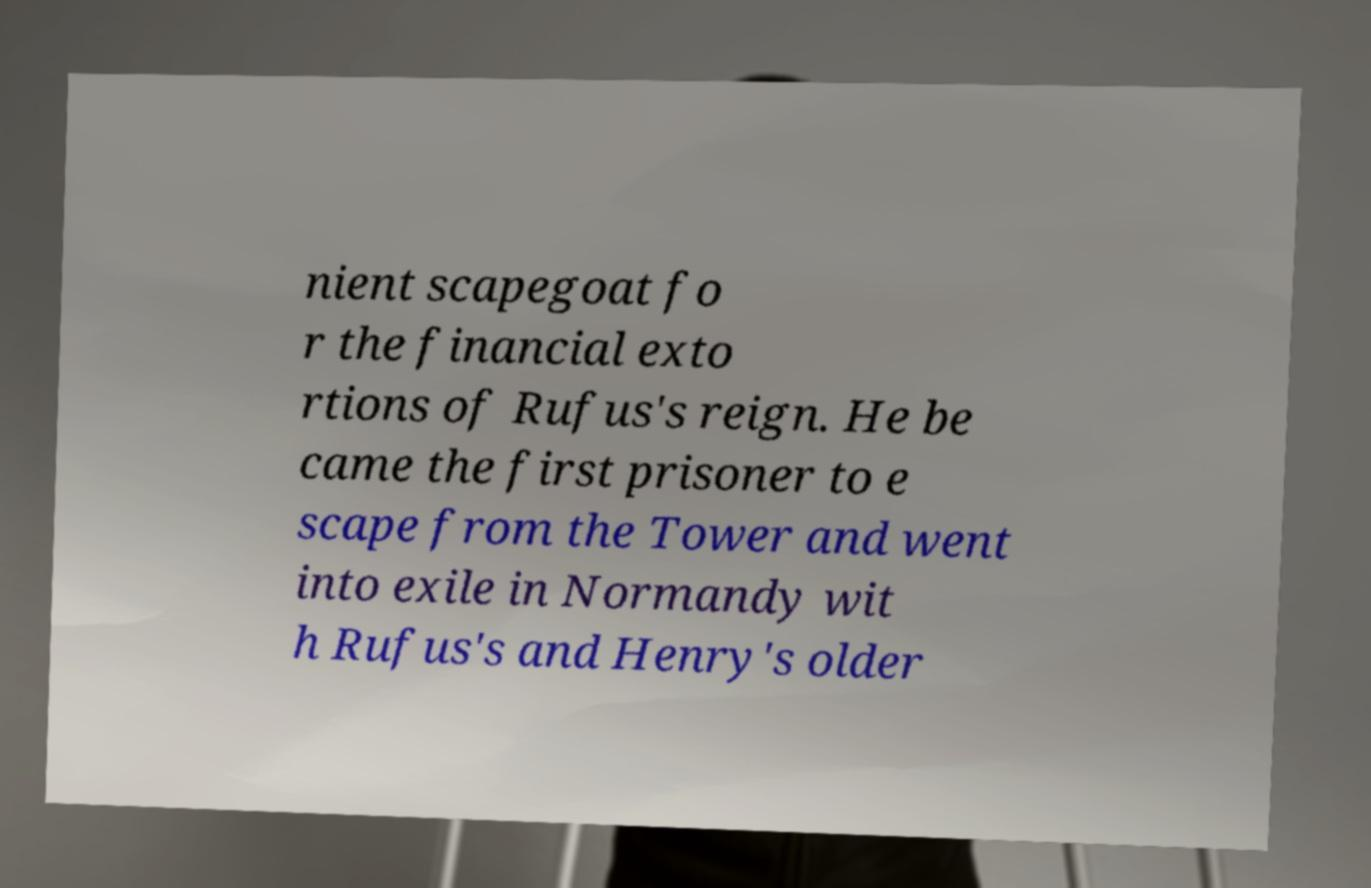Can you accurately transcribe the text from the provided image for me? nient scapegoat fo r the financial exto rtions of Rufus's reign. He be came the first prisoner to e scape from the Tower and went into exile in Normandy wit h Rufus's and Henry's older 